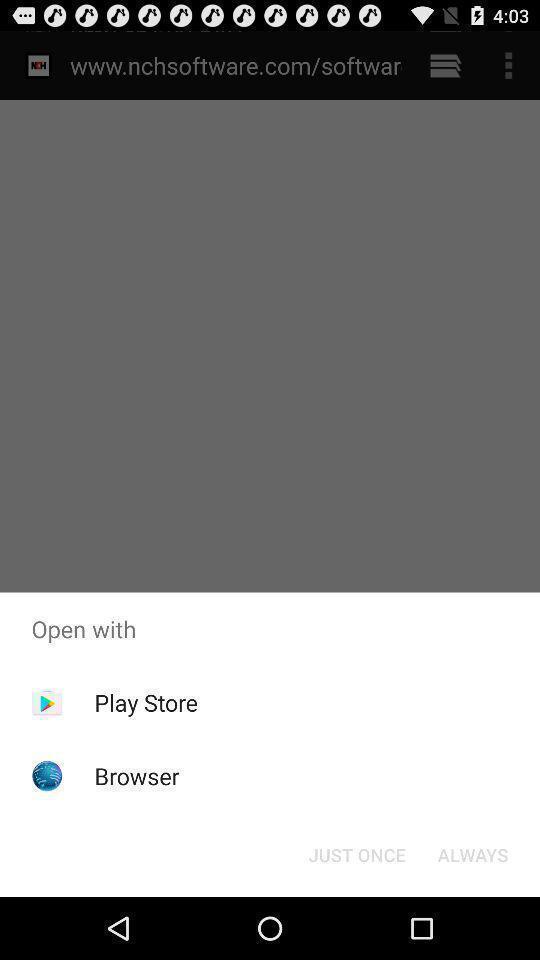Tell me about the visual elements in this screen capture. Pop-up displaying the app options to open. 